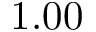<formula> <loc_0><loc_0><loc_500><loc_500>1 . 0 0</formula> 